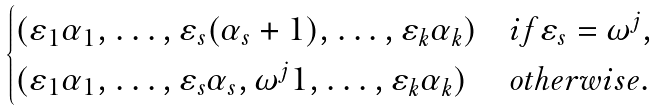<formula> <loc_0><loc_0><loc_500><loc_500>\begin{cases} ( \varepsilon _ { 1 } \alpha _ { 1 } , \dots , \varepsilon _ { s } ( \alpha _ { s } + 1 ) , \dots , \varepsilon _ { k } \alpha _ { k } ) & i f \varepsilon _ { s } = \omega ^ { j } , \\ ( \varepsilon _ { 1 } \alpha _ { 1 } , \dots , \varepsilon _ { s } \alpha _ { s } , \omega ^ { j } 1 , \dots , \varepsilon _ { k } \alpha _ { k } ) & o t h e r w i s e . \end{cases}</formula> 